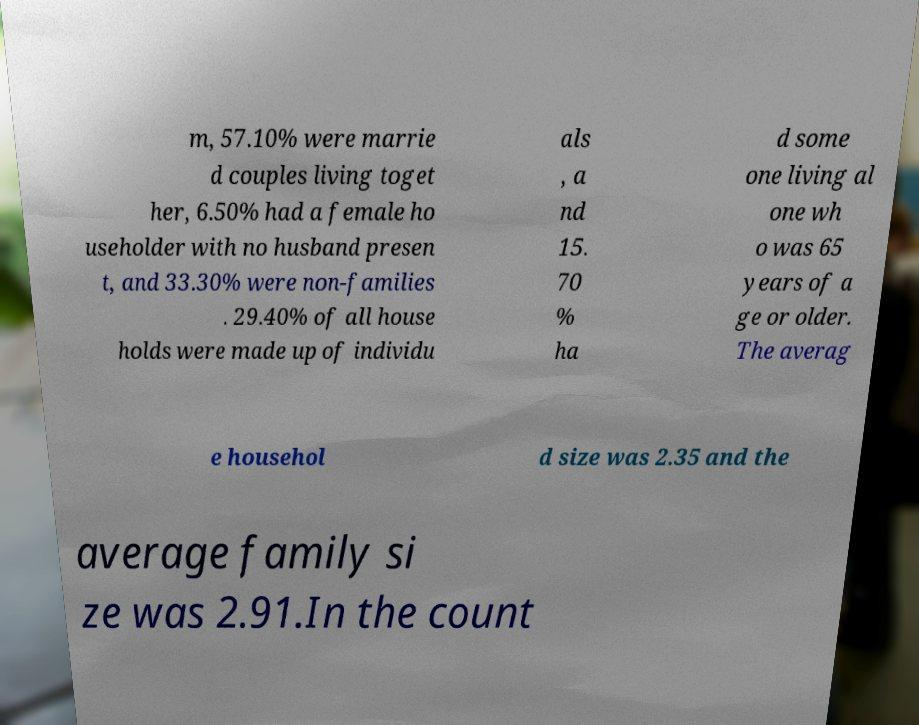I need the written content from this picture converted into text. Can you do that? m, 57.10% were marrie d couples living toget her, 6.50% had a female ho useholder with no husband presen t, and 33.30% were non-families . 29.40% of all house holds were made up of individu als , a nd 15. 70 % ha d some one living al one wh o was 65 years of a ge or older. The averag e househol d size was 2.35 and the average family si ze was 2.91.In the count 